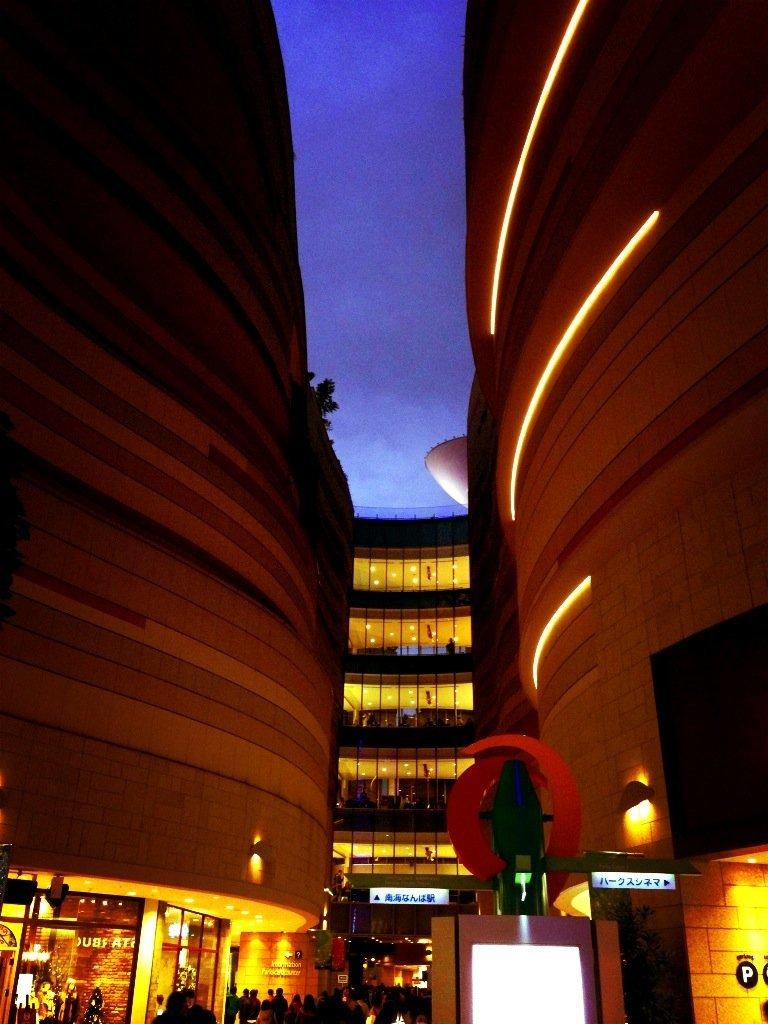What type of structures can be seen in the image? There are buildings in the image. What objects are present in the image that might be used for displaying information or advertisements? There are boards and hoardings in the image. What can be seen that might provide illumination in the image? There are lights in the image. What objects might be used for drinking in the image? There are glasses in the image. Are there any people visible in the image? Yes, there are people in the image. What is visible in the background of the image? The sky is visible in the background of the image. What type of shoe can be seen in the image? There is no shoe present in the image. What is the rhythm of the music playing in the background of the image? There is no music or rhythm mentioned in the image. 